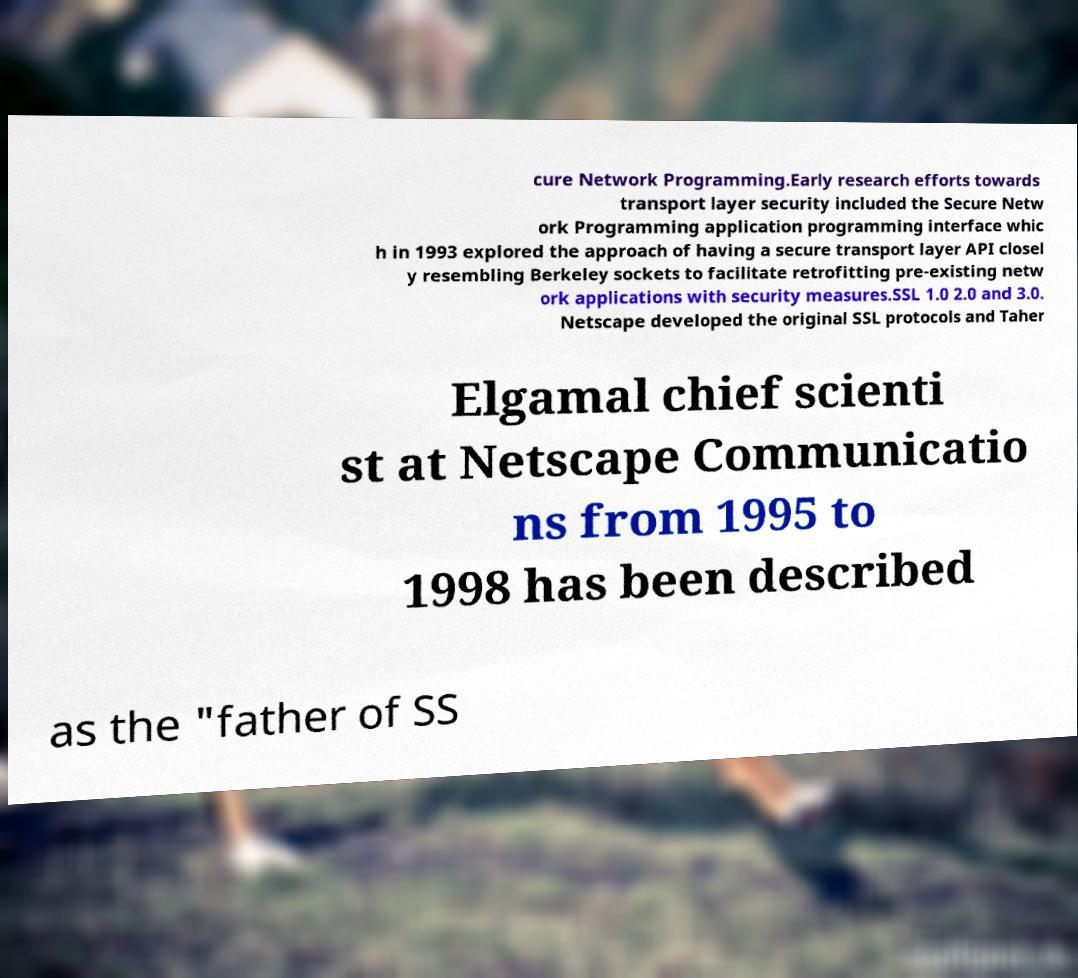Could you assist in decoding the text presented in this image and type it out clearly? cure Network Programming.Early research efforts towards transport layer security included the Secure Netw ork Programming application programming interface whic h in 1993 explored the approach of having a secure transport layer API closel y resembling Berkeley sockets to facilitate retrofitting pre-existing netw ork applications with security measures.SSL 1.0 2.0 and 3.0. Netscape developed the original SSL protocols and Taher Elgamal chief scienti st at Netscape Communicatio ns from 1995 to 1998 has been described as the "father of SS 